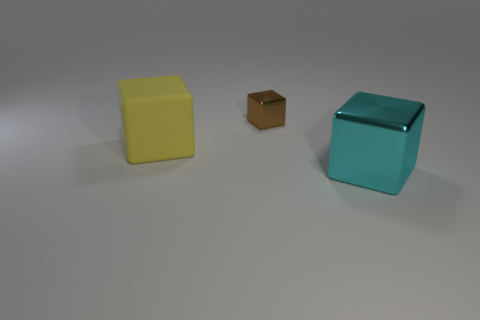Comparing the sizes of the cubes, which one is the largest and which is the smallest? The cyan cube appears to be the largest, while the brown cube is the smallest among the three. Can you tell if the surfaces the cubes are resting on have any texture or patterns? The surfaces are uniformly lit with a neutral grey tone and there are no visible textures or patterns, giving the setting a minimalistic appearance. 